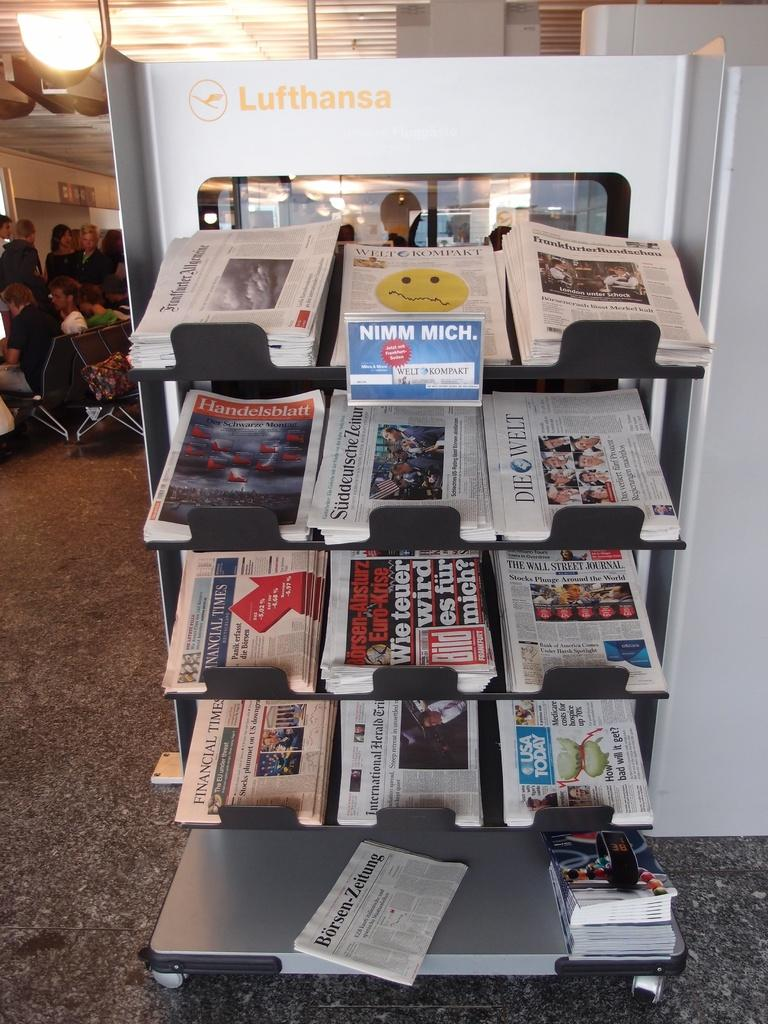<image>
Offer a succinct explanation of the picture presented. A small newspaper display features USA Today, the Wall Street Journal and Die Welt. 